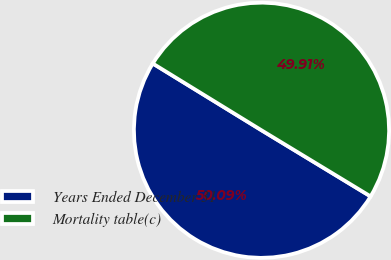Convert chart to OTSL. <chart><loc_0><loc_0><loc_500><loc_500><pie_chart><fcel>Years Ended December 31<fcel>Mortality table(c)<nl><fcel>50.09%<fcel>49.91%<nl></chart> 